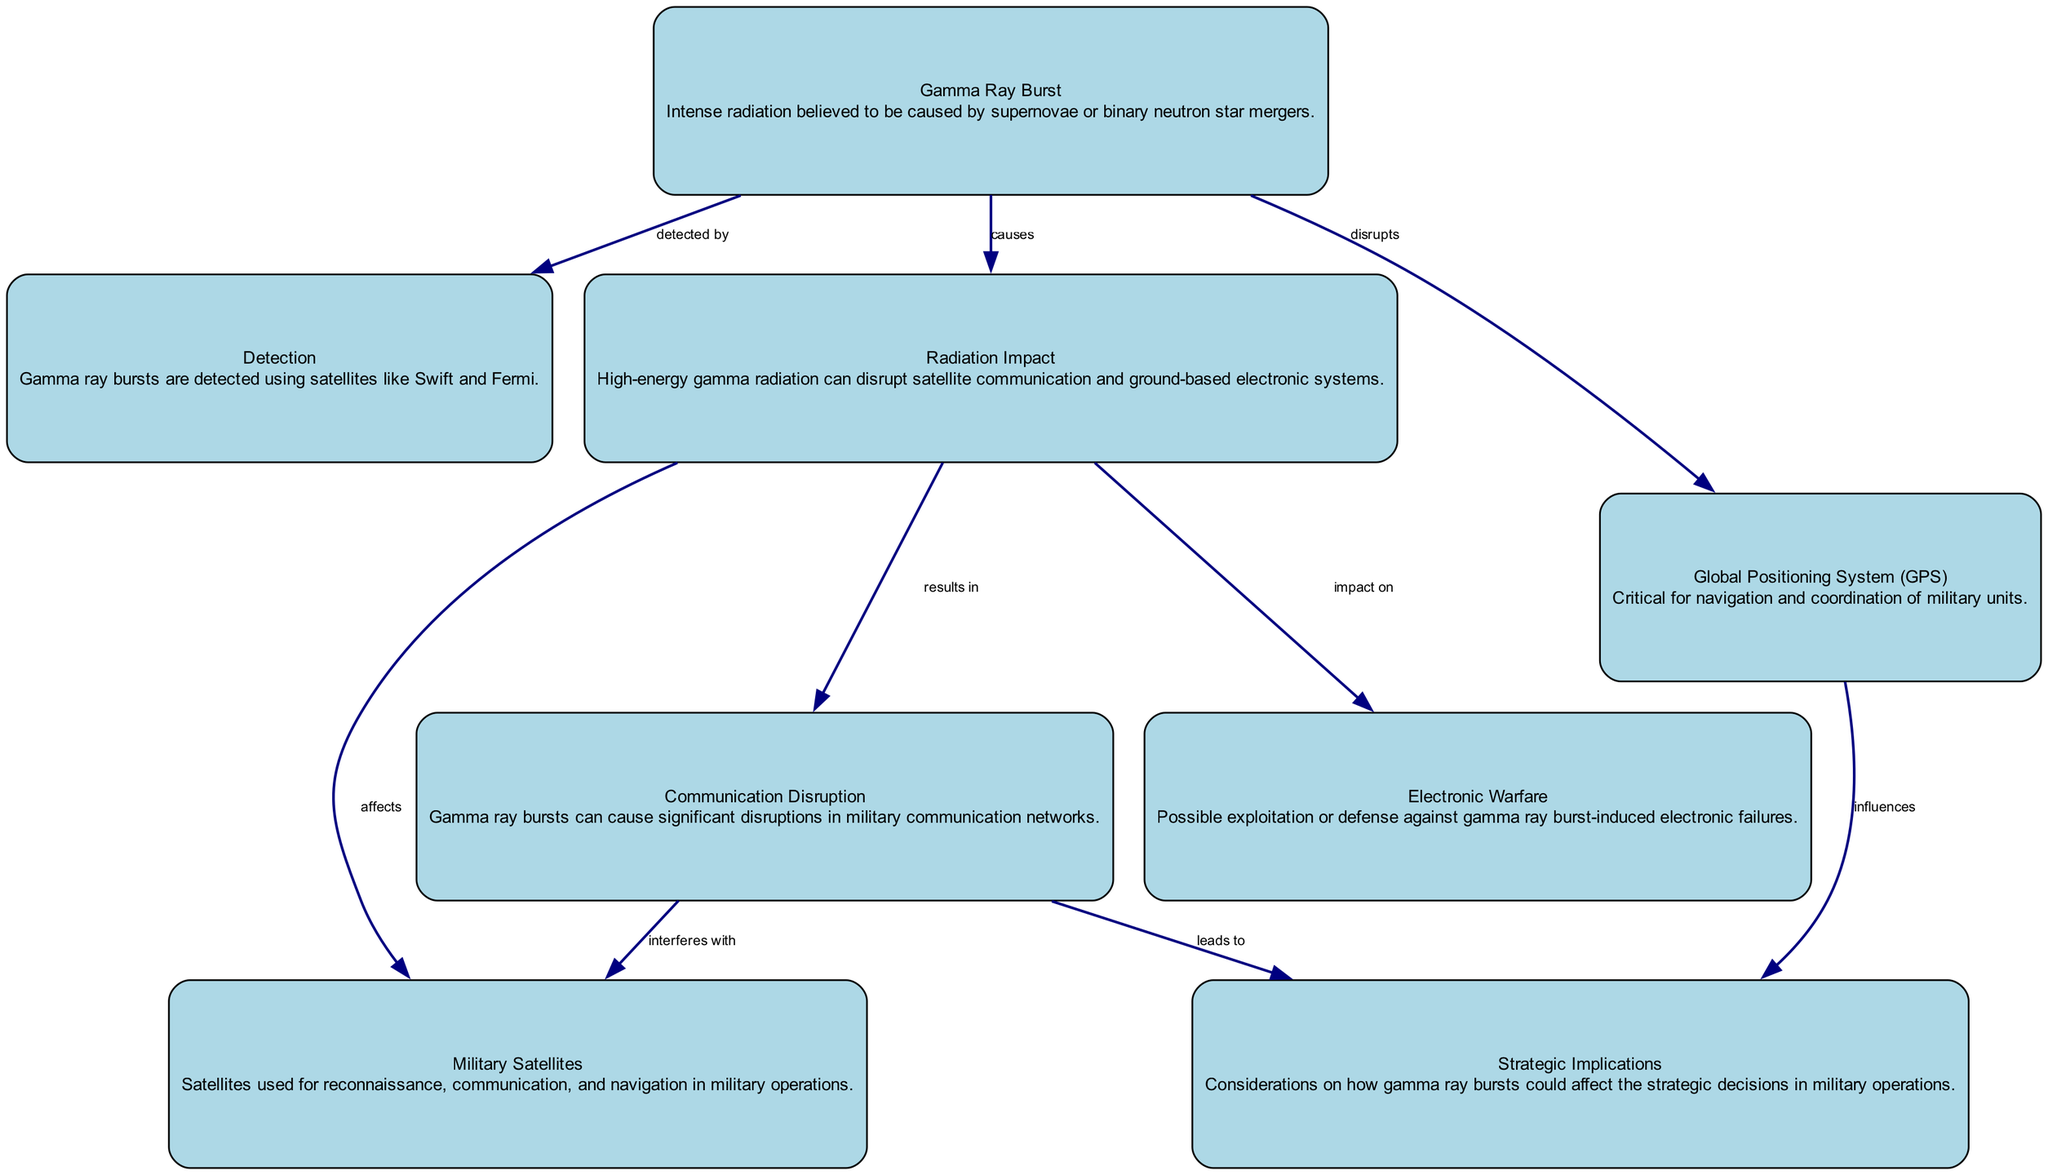What's the total number of nodes in the diagram? The diagram lists 8 distinct nodes including "Gamma Ray Burst," "Detection," "Radiation Impact," "Military Satellites," "Communication Disruption," "Electronic Warfare," "Global Positioning System," and "Strategic Implications." Counting these gives a total of 8 nodes.
Answer: 8 What is the relationship between Gamma Ray Burst and Detection? According to the diagram, "Gamma Ray Burst" is connected to "Detection" with the label "detected by," indicating that Gamma Ray Bursts are identified through detection methods.
Answer: detected by Which node is directly affected by Radiation Impact? The nodes directly affected by the "Radiation Impact" are "Military Satellites" and "Communication Disruption," as shown in the edges stemming from "Radiation Impact."
Answer: Military Satellites, Communication Disruption How does Communication Disruption impact Strategic Implications? The diagram indicates that "Communication Disruption" leads to "Strategic Implications," signifying that disruptions in communication can influence military strategy.
Answer: leads to What does Gamma Ray Burst disrupt specifically regarding military operations? "Gamma Ray Burst" is shown to disrupt the "Global Positioning System," which is critical for navigation in military operations, emphasizing the operational vulnerability due to these bursts.
Answer: Global Positioning System What is a potential defense against Gamma Ray Burst-induced issues in military operations? The diagram highlights "Electronic Warfare" as a potential response by suggesting it could involve either exploiting or defending against the electronic failures resulting from Radiation Impact.
Answer: Electronic Warfare How many edges are there between the nodes and what do most of them relate to? The diagram contains 8 edges, most of which relate to the impact of Gamma Ray Bursts on various military operations, such as communication and satellite functionality.
Answer: 8, impact of Gamma Ray Bursts Which node directly influences military satellite operations through Radiation Impact? The "Military Satellites" node is directly affected as "Radiation Impact" leads to interference with their functions, as represented in the diagram's connections.
Answer: Military Satellites 